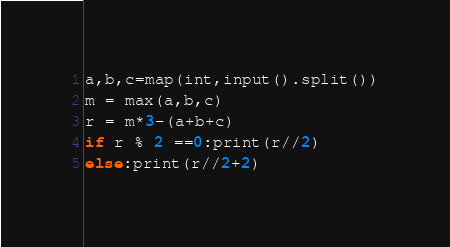<code> <loc_0><loc_0><loc_500><loc_500><_Python_>a,b,c=map(int,input().split())
m = max(a,b,c)
r = m*3-(a+b+c)
if r % 2 ==0:print(r//2)
else:print(r//2+2)</code> 